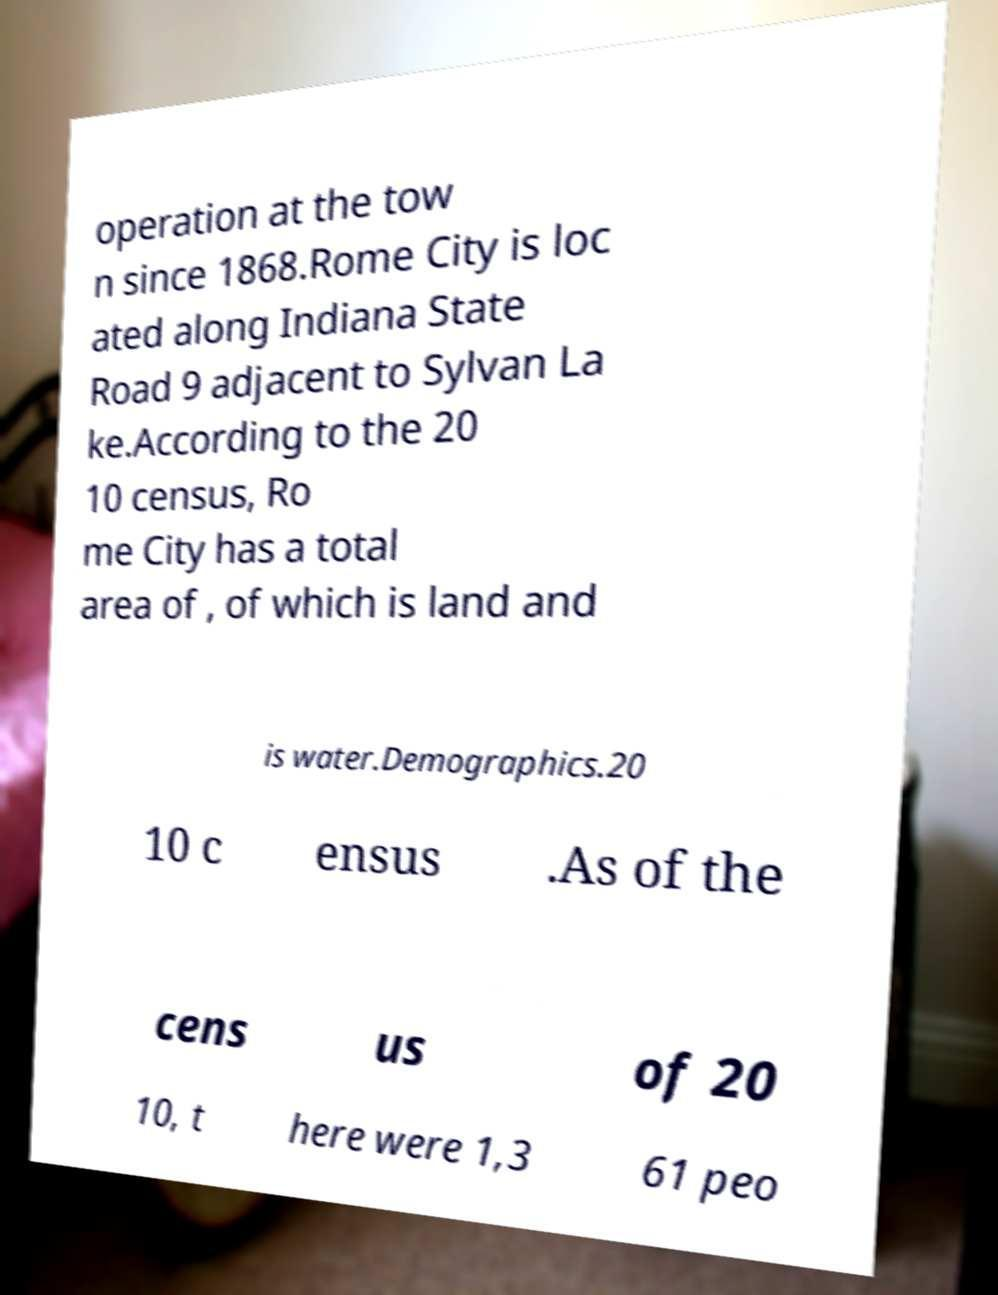What messages or text are displayed in this image? I need them in a readable, typed format. operation at the tow n since 1868.Rome City is loc ated along Indiana State Road 9 adjacent to Sylvan La ke.According to the 20 10 census, Ro me City has a total area of , of which is land and is water.Demographics.20 10 c ensus .As of the cens us of 20 10, t here were 1,3 61 peo 